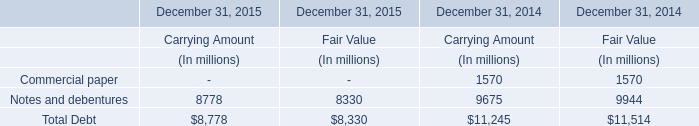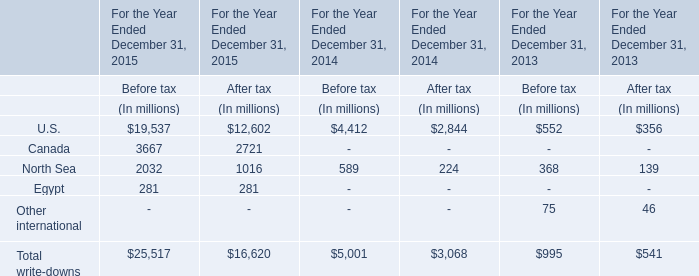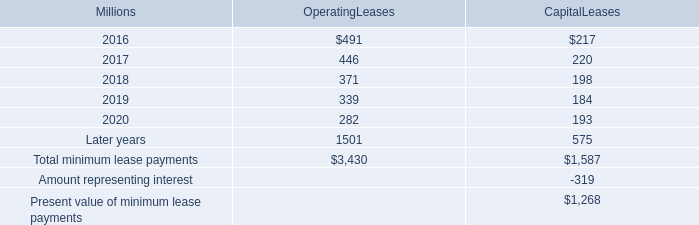What's the average of Before tax in U.S. in 2013, 2014, and 2015? (in million) 
Computations: (((19537 + 4412) + 552) / 3)
Answer: 8167.0. in the consolidated statement of financial position what was the ratio of the properties held under capital leases in 2015 to 2014\\n 
Computations: (2273 / 2454)
Answer: 0.92624. 